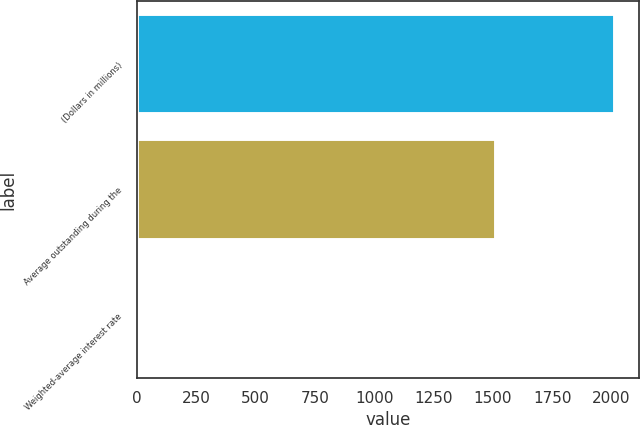Convert chart. <chart><loc_0><loc_0><loc_500><loc_500><bar_chart><fcel>(Dollars in millions)<fcel>Average outstanding during the<fcel>Weighted-average interest rate<nl><fcel>2016<fcel>1512<fcel>0.36<nl></chart> 